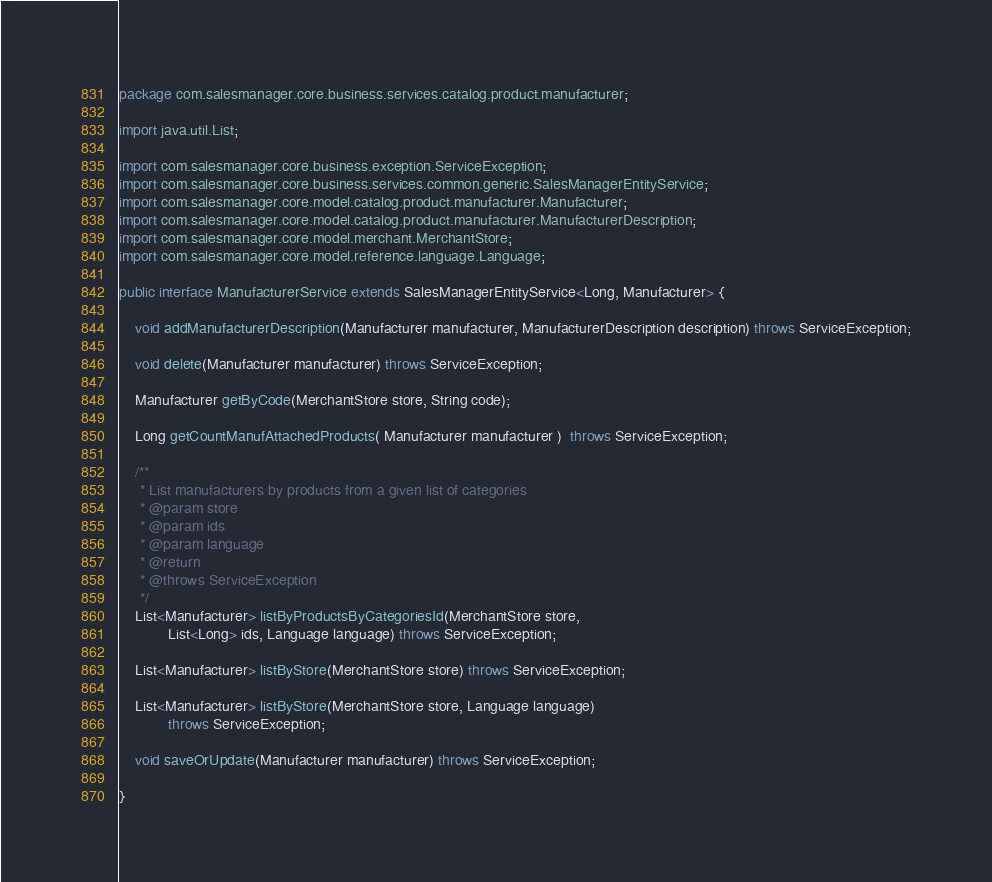Convert code to text. <code><loc_0><loc_0><loc_500><loc_500><_Java_>package com.salesmanager.core.business.services.catalog.product.manufacturer;

import java.util.List;

import com.salesmanager.core.business.exception.ServiceException;
import com.salesmanager.core.business.services.common.generic.SalesManagerEntityService;
import com.salesmanager.core.model.catalog.product.manufacturer.Manufacturer;
import com.salesmanager.core.model.catalog.product.manufacturer.ManufacturerDescription;
import com.salesmanager.core.model.merchant.MerchantStore;
import com.salesmanager.core.model.reference.language.Language;

public interface ManufacturerService extends SalesManagerEntityService<Long, Manufacturer> {

	void addManufacturerDescription(Manufacturer manufacturer, ManufacturerDescription description) throws ServiceException;

	void delete(Manufacturer manufacturer) throws ServiceException;

	Manufacturer getByCode(MerchantStore store, String code);
	
	Long getCountManufAttachedProducts( Manufacturer manufacturer )  throws ServiceException;
	
	/**
	 * List manufacturers by products from a given list of categories
	 * @param store
	 * @param ids
	 * @param language
	 * @return
	 * @throws ServiceException
	 */
	List<Manufacturer> listByProductsByCategoriesId(MerchantStore store,
			List<Long> ids, Language language) throws ServiceException;
	
	List<Manufacturer> listByStore(MerchantStore store) throws ServiceException;
	
	List<Manufacturer> listByStore(MerchantStore store, Language language)
			throws ServiceException;

	void saveOrUpdate(Manufacturer manufacturer) throws ServiceException;
	
}
</code> 